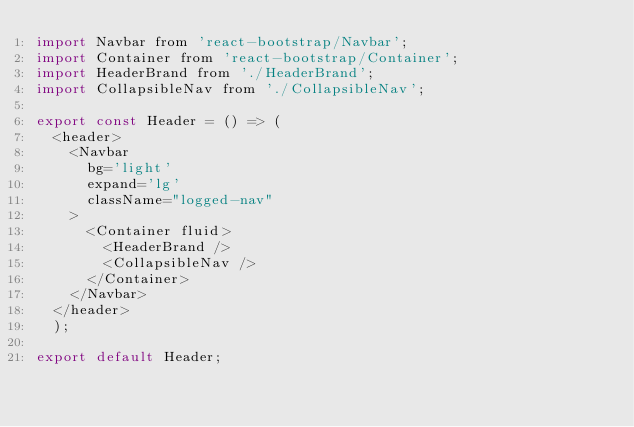<code> <loc_0><loc_0><loc_500><loc_500><_JavaScript_>import Navbar from 'react-bootstrap/Navbar';
import Container from 'react-bootstrap/Container';
import HeaderBrand from './HeaderBrand';
import CollapsibleNav from './CollapsibleNav';

export const Header = () => (
  <header>
    <Navbar
      bg='light'
      expand='lg'
      className="logged-nav"
    >
      <Container fluid>
        <HeaderBrand />
        <CollapsibleNav />
      </Container>
    </Navbar>
  </header>
  );

export default Header;
</code> 